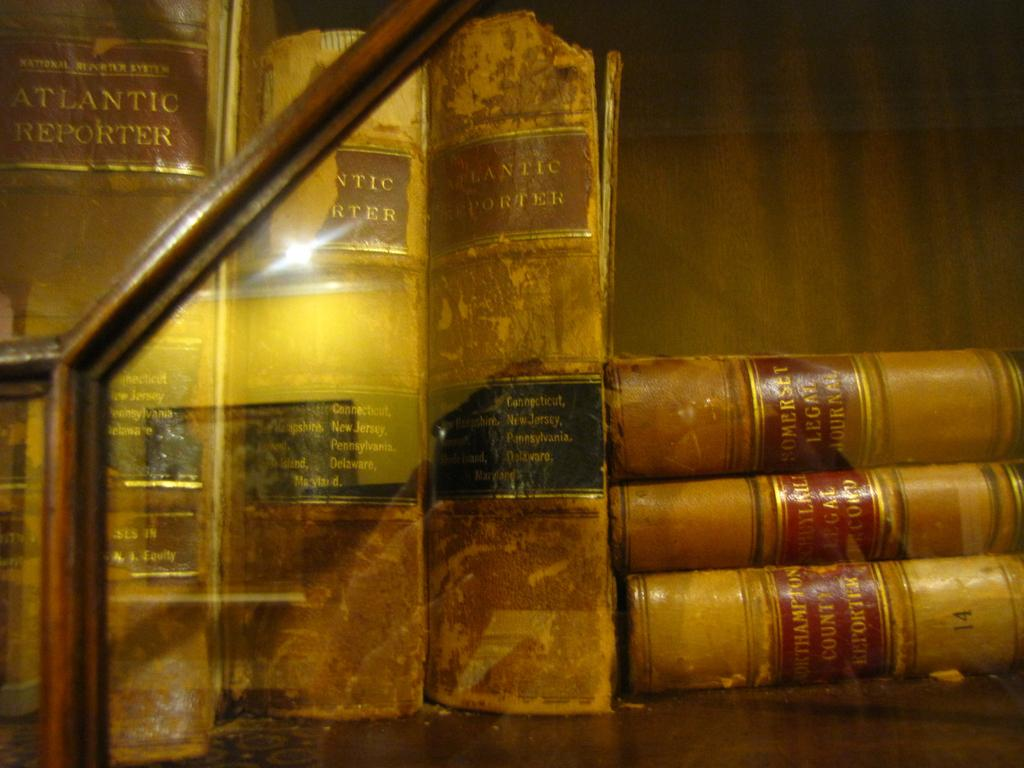<image>
Create a compact narrative representing the image presented. The old book on the left side of the case is titled Atlantic Reporter 